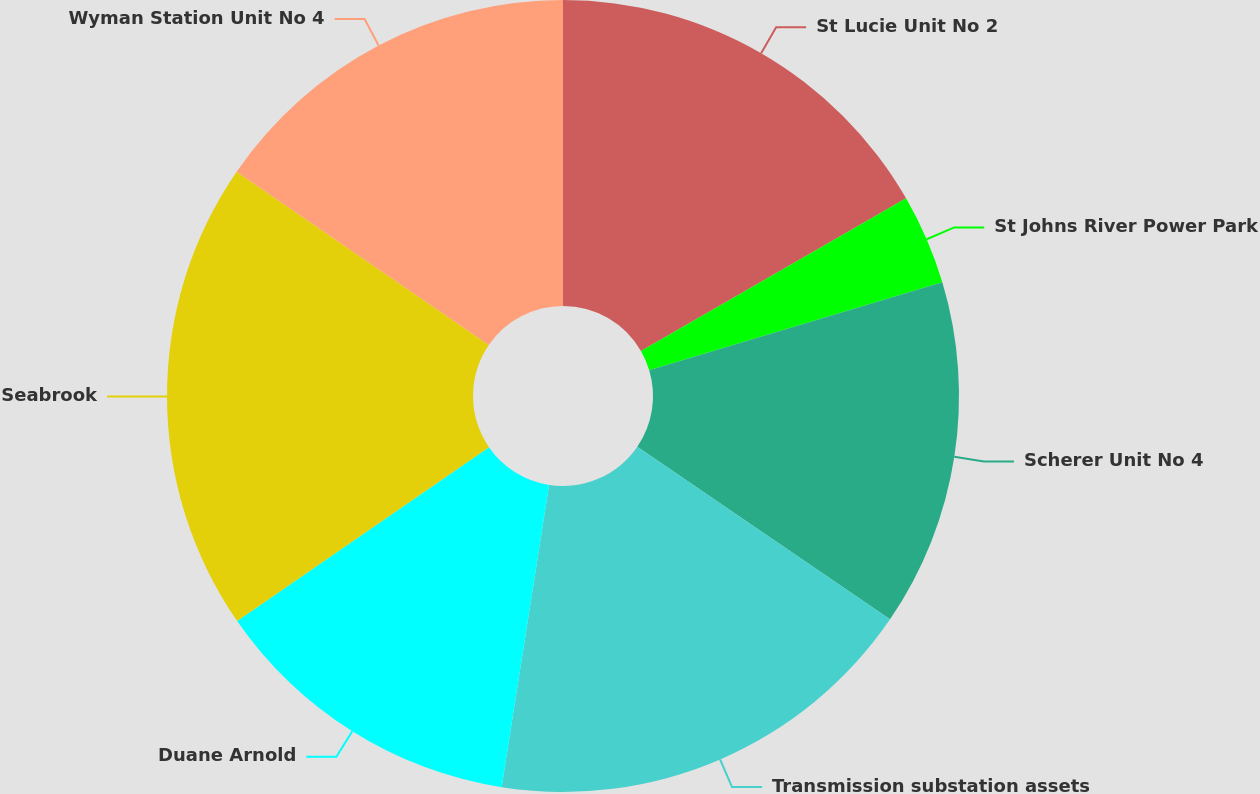Convert chart. <chart><loc_0><loc_0><loc_500><loc_500><pie_chart><fcel>St Lucie Unit No 2<fcel>St Johns River Power Park<fcel>Scherer Unit No 4<fcel>Transmission substation assets<fcel>Duane Arnold<fcel>Seabrook<fcel>Wyman Station Unit No 4<nl><fcel>16.68%<fcel>3.69%<fcel>14.17%<fcel>17.94%<fcel>12.91%<fcel>19.2%<fcel>15.42%<nl></chart> 